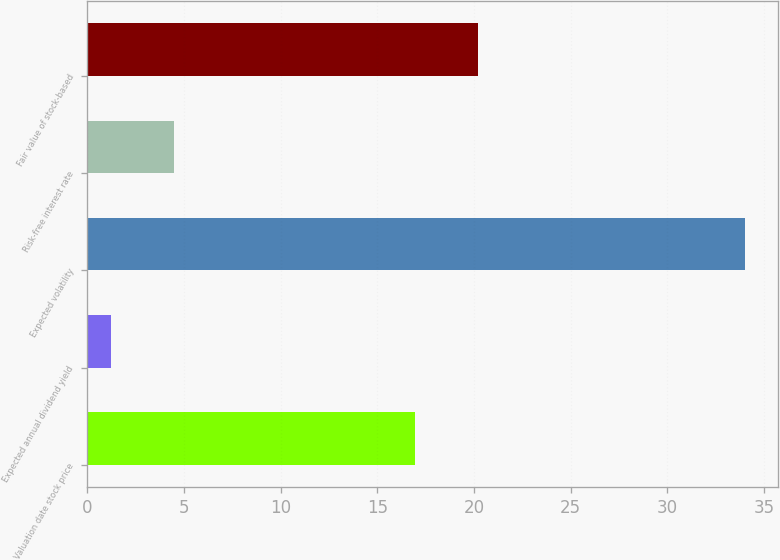Convert chart. <chart><loc_0><loc_0><loc_500><loc_500><bar_chart><fcel>Valuation date stock price<fcel>Expected annual dividend yield<fcel>Expected volatility<fcel>Risk-free interest rate<fcel>Fair value of stock-based<nl><fcel>16.93<fcel>1.2<fcel>34<fcel>4.48<fcel>20.21<nl></chart> 